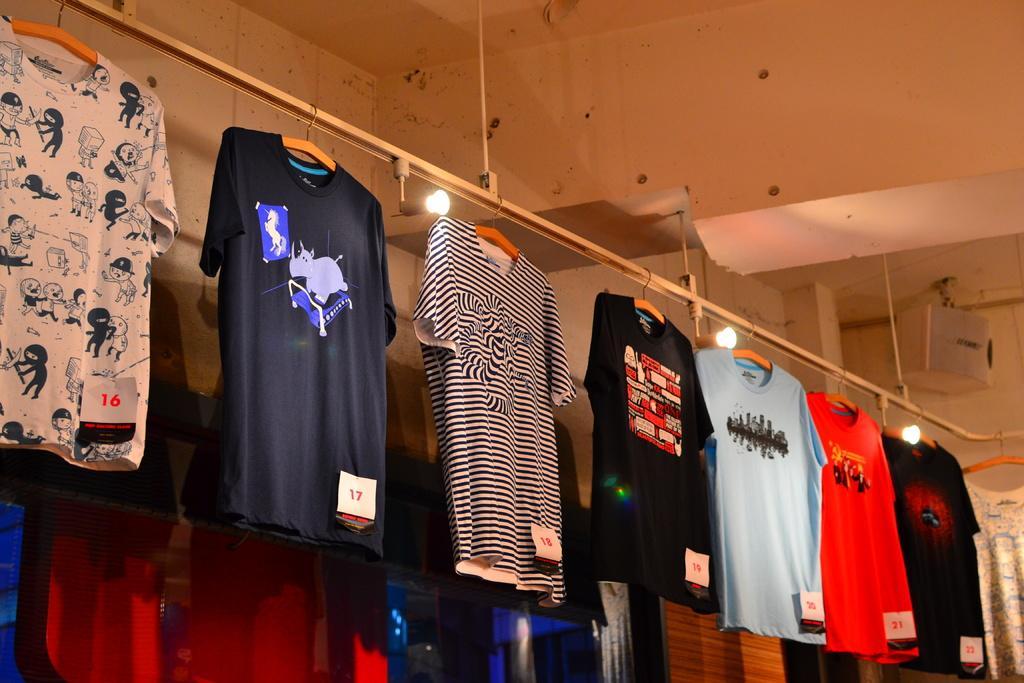Describe this image in one or two sentences. In this picture we can see few t-shirts in the front, in the background there is a wall and three lights. 